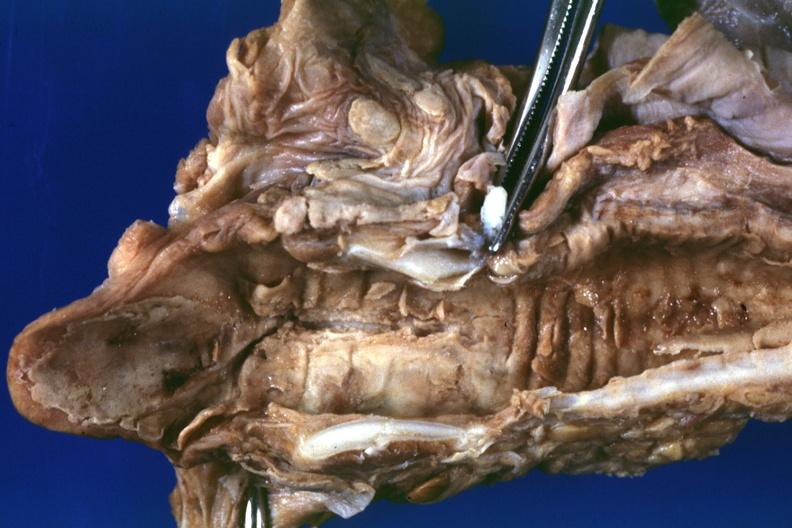what is present?
Answer the question using a single word or phrase. Larynx 